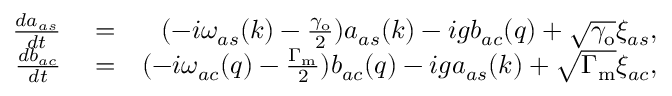Convert formula to latex. <formula><loc_0><loc_0><loc_500><loc_500>\begin{array} { r l r } { \frac { d a _ { a s } } { d t } } & = } & { ( - i \omega _ { a s } ( k ) - \frac { \gamma _ { o } } { 2 } ) a _ { a s } ( k ) - i g b _ { a c } ( q ) + \sqrt { \gamma _ { o } } \xi _ { a s } , } \\ { \frac { d b _ { a c } } { d t } } & = } & { ( - i \omega _ { a c } ( q ) - \frac { \Gamma _ { m } } { 2 } ) b _ { a c } ( q ) - i g a _ { a s } ( k ) + \sqrt { \Gamma _ { m } } \xi _ { a c } , } \end{array}</formula> 